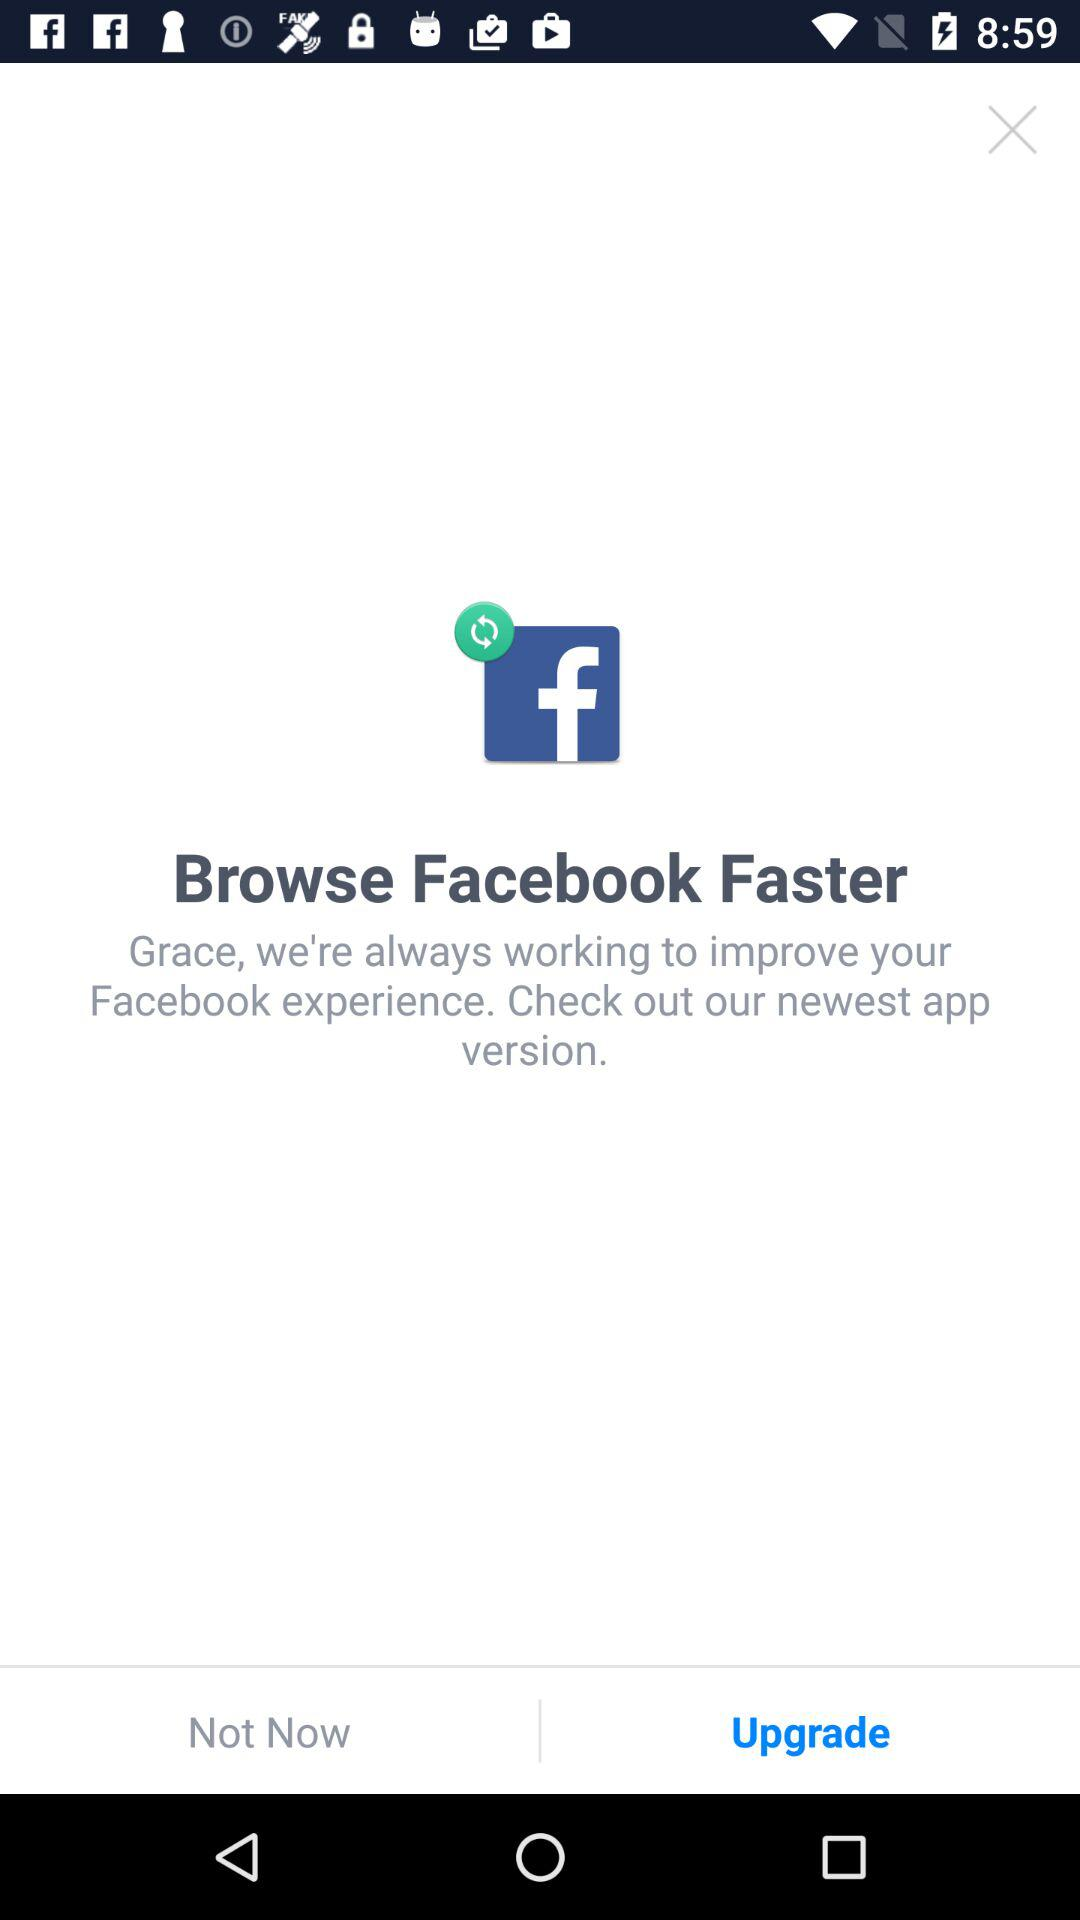What is the application name? The application name is "Facebook". 